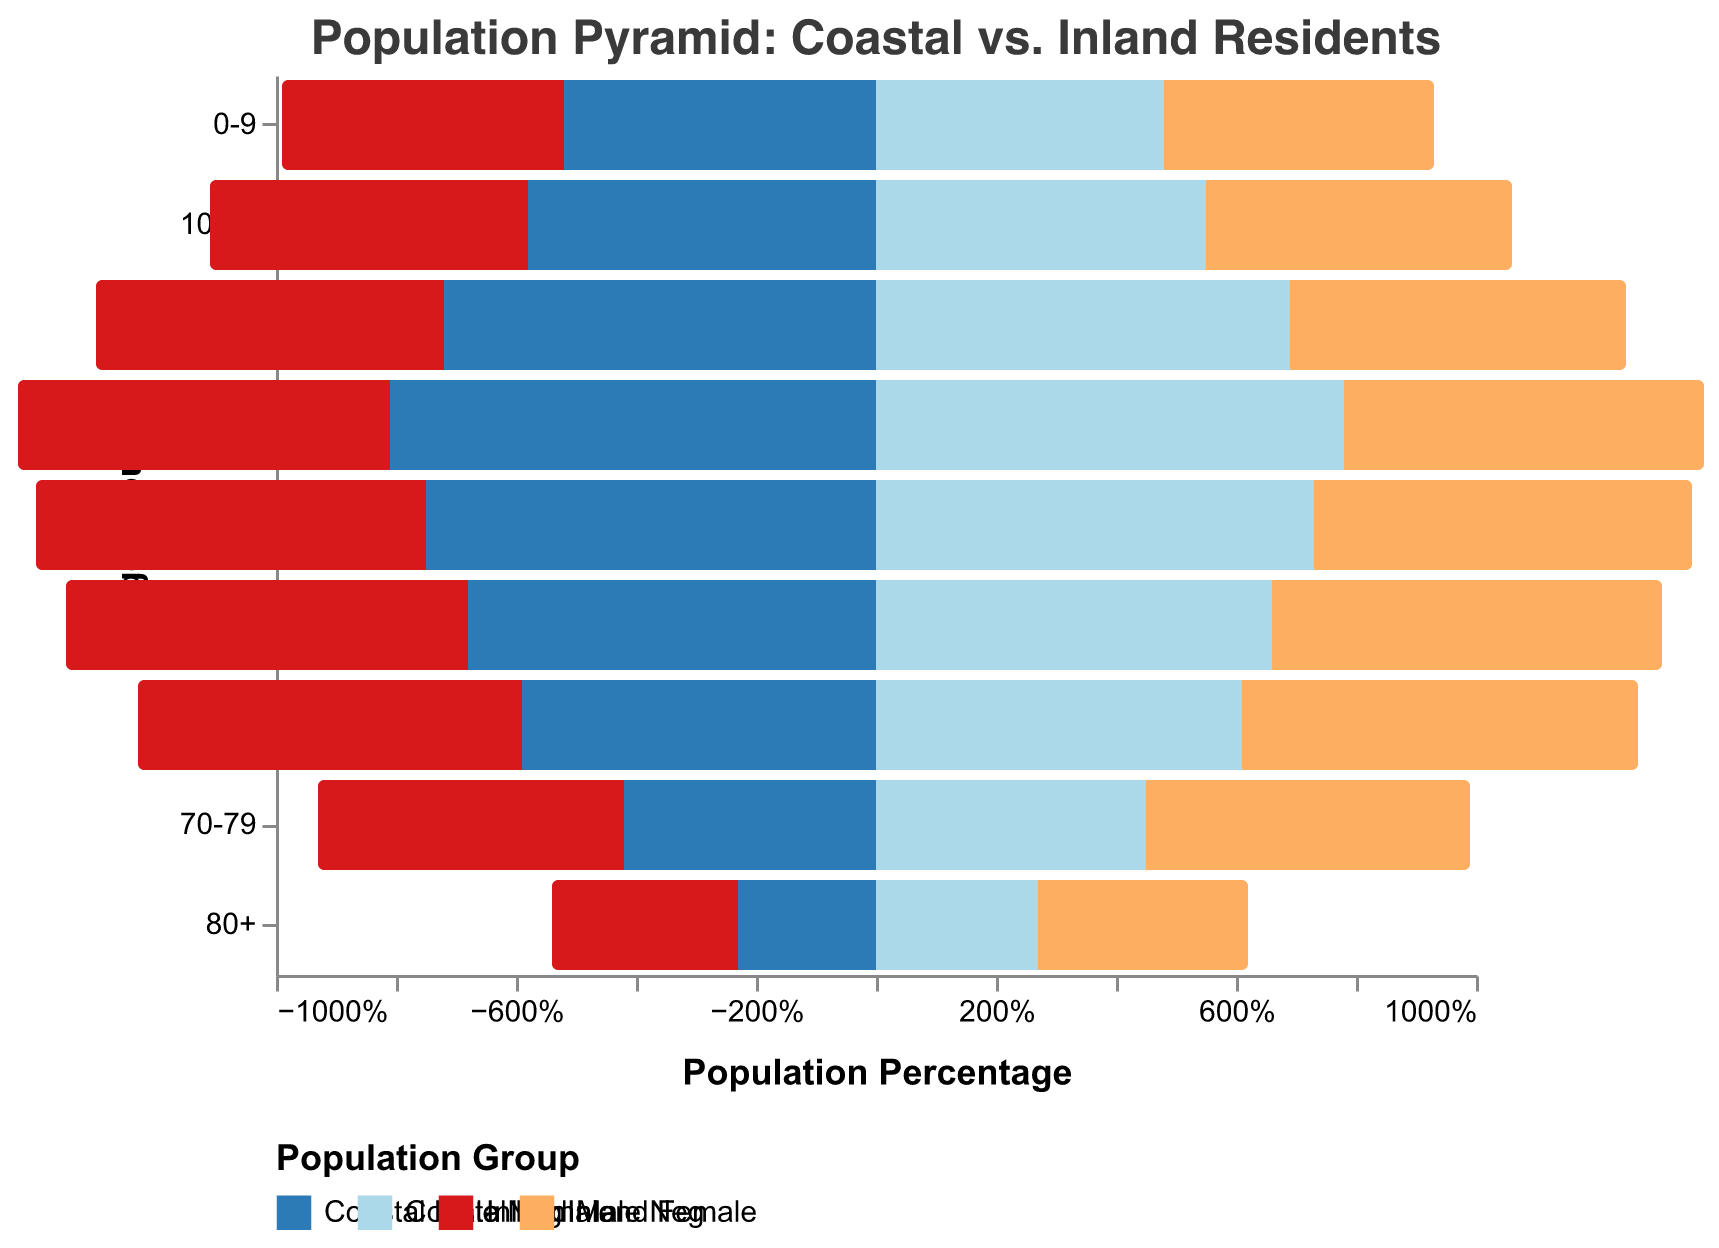What's the age group with the highest percentage of Coastal residents? Look for the age group with the highest percentage values for both Coastal Male and Coastal Female categories. The highest percentages are for the age group 30-39 with 8.1% for males and 7.8% for females.
Answer: 30-39 How does the percentage of Coastal Males in the 20-29 age group compare to Inland Males in the same age group? Look at the percentage bars for Coastal Males and Inland Males in the 20-29 age group. Coastal Males have a percentage of 7.2%, while Inland Males have 5.8%. 7.2% is greater than 5.8%.
Answer: Coastal Males are higher Which age group shows a noticeable decline in the percentage of Coastal residents compared to the preceding age group? Observe the pattern across the age groups for Coastal Male and Coastal Female. There is a noticeable decline from the 30-39 group (8.1%, 7.8%) to the 40-49 group (7.5%, 7.3%).
Answer: 40-49 For which age group are Coastal Females almost equal to Inland Females? Compare the percentages of Coastal and Inland Females across different age groups. For the age group 50-59, Coastal Females are 6.6% and Inland Females are 6.5%, which are almost equal.
Answer: 50-59 What is the difference in percentage between Coastal Males and Coastal Females in the 60-69 age group? Find the percentage values for both Coastal Male and Coastal Female in the 60-69 age group. Coastal Male is 5.9%, and Coastal Female is 6.1%. The difference is 6.1% - 5.9%.
Answer: 0.2% Which age group has the largest disparity between Coastal and Inland residents? Evaluate the difference between Coastal and Inland residents for each age group and find the maximum disparity. For the age group 30-39, Coastal Males and Females sum to 15.9%, while Inland Males and Females sum to 12.2%. The disparity is 3.7%.
Answer: 30-39 What is the trend of Inland Males' percentages as age increases? Observe the Inland Male percentages from the youngest to the oldest age group. The percentages generally decrease from 4.7% to 3.1% as age increases.
Answer: Decreasing 